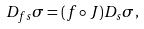Convert formula to latex. <formula><loc_0><loc_0><loc_500><loc_500>D _ { f s } \sigma = ( f \circ J ) D _ { s } \sigma ,</formula> 